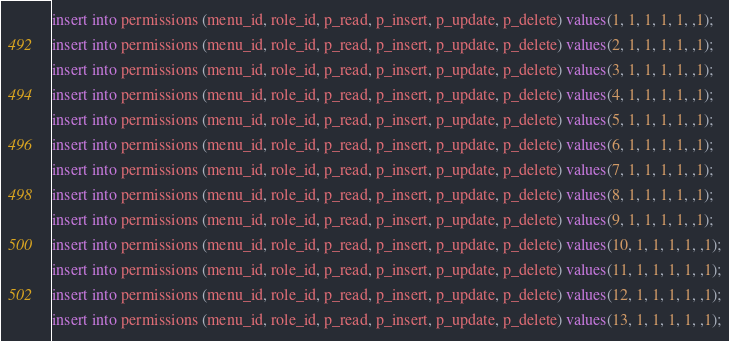<code> <loc_0><loc_0><loc_500><loc_500><_SQL_>insert into permissions (menu_id, role_id, p_read, p_insert, p_update, p_delete) values(1, 1, 1, 1, 1, ,1);
insert into permissions (menu_id, role_id, p_read, p_insert, p_update, p_delete) values(2, 1, 1, 1, 1, ,1);
insert into permissions (menu_id, role_id, p_read, p_insert, p_update, p_delete) values(3, 1, 1, 1, 1, ,1);
insert into permissions (menu_id, role_id, p_read, p_insert, p_update, p_delete) values(4, 1, 1, 1, 1, ,1);
insert into permissions (menu_id, role_id, p_read, p_insert, p_update, p_delete) values(5, 1, 1, 1, 1, ,1);
insert into permissions (menu_id, role_id, p_read, p_insert, p_update, p_delete) values(6, 1, 1, 1, 1, ,1);
insert into permissions (menu_id, role_id, p_read, p_insert, p_update, p_delete) values(7, 1, 1, 1, 1, ,1);
insert into permissions (menu_id, role_id, p_read, p_insert, p_update, p_delete) values(8, 1, 1, 1, 1, ,1);
insert into permissions (menu_id, role_id, p_read, p_insert, p_update, p_delete) values(9, 1, 1, 1, 1, ,1);
insert into permissions (menu_id, role_id, p_read, p_insert, p_update, p_delete) values(10, 1, 1, 1, 1, ,1);
insert into permissions (menu_id, role_id, p_read, p_insert, p_update, p_delete) values(11, 1, 1, 1, 1, ,1);
insert into permissions (menu_id, role_id, p_read, p_insert, p_update, p_delete) values(12, 1, 1, 1, 1, ,1);
insert into permissions (menu_id, role_id, p_read, p_insert, p_update, p_delete) values(13, 1, 1, 1, 1, ,1);</code> 